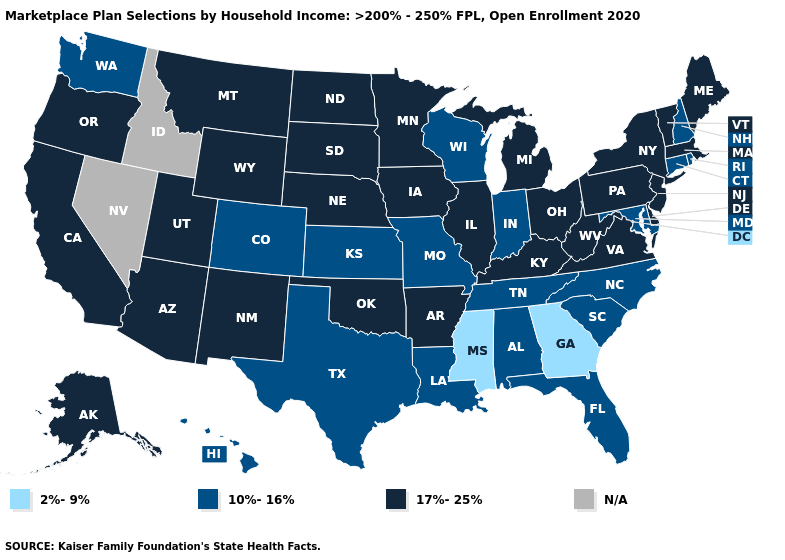Does the map have missing data?
Give a very brief answer. Yes. What is the lowest value in states that border Idaho?
Answer briefly. 10%-16%. Does Florida have the lowest value in the South?
Write a very short answer. No. What is the value of Kentucky?
Short answer required. 17%-25%. What is the value of Connecticut?
Give a very brief answer. 10%-16%. How many symbols are there in the legend?
Give a very brief answer. 4. What is the lowest value in states that border Pennsylvania?
Concise answer only. 10%-16%. Name the states that have a value in the range 10%-16%?
Keep it brief. Alabama, Colorado, Connecticut, Florida, Hawaii, Indiana, Kansas, Louisiana, Maryland, Missouri, New Hampshire, North Carolina, Rhode Island, South Carolina, Tennessee, Texas, Washington, Wisconsin. Among the states that border Massachusetts , which have the lowest value?
Short answer required. Connecticut, New Hampshire, Rhode Island. What is the highest value in states that border North Carolina?
Concise answer only. 17%-25%. Which states have the highest value in the USA?
Answer briefly. Alaska, Arizona, Arkansas, California, Delaware, Illinois, Iowa, Kentucky, Maine, Massachusetts, Michigan, Minnesota, Montana, Nebraska, New Jersey, New Mexico, New York, North Dakota, Ohio, Oklahoma, Oregon, Pennsylvania, South Dakota, Utah, Vermont, Virginia, West Virginia, Wyoming. Does Georgia have the lowest value in the USA?
Give a very brief answer. Yes. What is the value of Montana?
Short answer required. 17%-25%. Among the states that border Oregon , which have the lowest value?
Write a very short answer. Washington. What is the value of Texas?
Keep it brief. 10%-16%. 